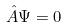Convert formula to latex. <formula><loc_0><loc_0><loc_500><loc_500>\hat { A } \Psi = 0</formula> 